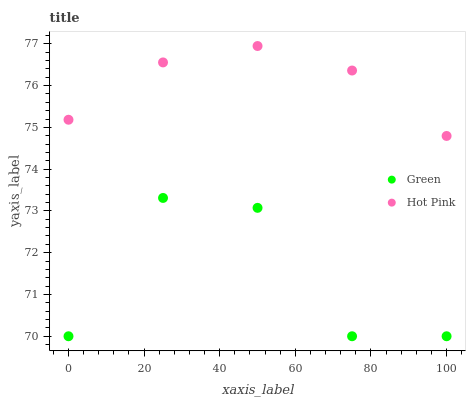Does Green have the minimum area under the curve?
Answer yes or no. Yes. Does Hot Pink have the maximum area under the curve?
Answer yes or no. Yes. Does Green have the maximum area under the curve?
Answer yes or no. No. Is Hot Pink the smoothest?
Answer yes or no. Yes. Is Green the roughest?
Answer yes or no. Yes. Is Green the smoothest?
Answer yes or no. No. Does Green have the lowest value?
Answer yes or no. Yes. Does Hot Pink have the highest value?
Answer yes or no. Yes. Does Green have the highest value?
Answer yes or no. No. Is Green less than Hot Pink?
Answer yes or no. Yes. Is Hot Pink greater than Green?
Answer yes or no. Yes. Does Green intersect Hot Pink?
Answer yes or no. No. 